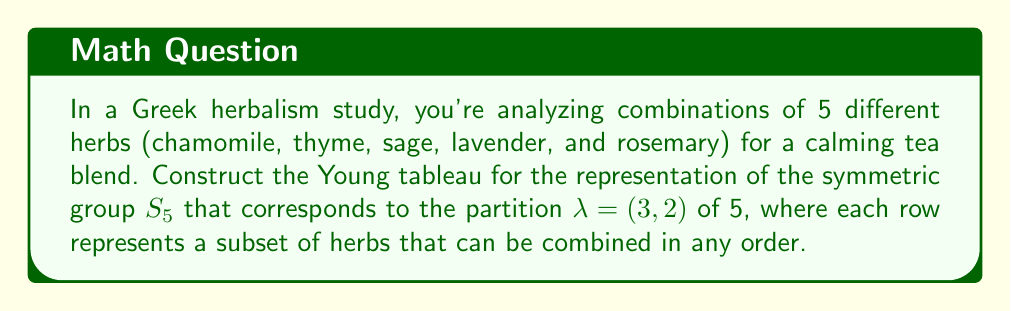What is the answer to this math problem? To construct the Young tableau for the representation of $S_5$ corresponding to the partition $\lambda = (3,2)$, we follow these steps:

1. Draw the Young diagram for $\lambda = (3,2)$:
   It consists of two rows, with 3 boxes in the first row and 2 boxes in the second row.

2. Fill in the boxes with the numbers 1 to 5 (representing the herbs) in increasing order from left to right and top to bottom:

   $$
   \begin{array}{|c|c|c|}
   \hline
   1 & 2 & 3 \\
   \hline
   4 & 5 & \\
   \hline
   \end{array}
   $$

3. This Young tableau represents a standard tableau for the given partition.

4. Interpret the tableau in terms of herb combinations:
   - Row 1 (1,2,3) represents the subset {chamomile, thyme, sage}
   - Row 2 (4,5) represents the subset {lavender, rosemary}

5. The representation corresponds to ways of arranging these two subsets of herbs, where the order within each subset can vary.

This Young tableau encodes information about the structure of the representation, including its dimension and character values, which can be useful in analyzing different herb combination formulas.
Answer: $$
\begin{array}{|c|c|c|}
\hline
1 & 2 & 3 \\
\hline
4 & 5 & \\
\hline
\end{array}
$$ 